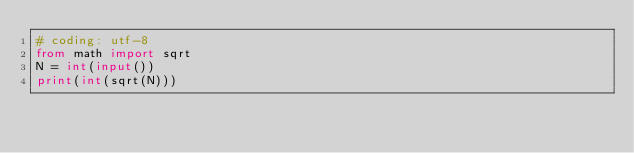<code> <loc_0><loc_0><loc_500><loc_500><_Python_># coding: utf-8
from math import sqrt
N = int(input())
print(int(sqrt(N)))</code> 